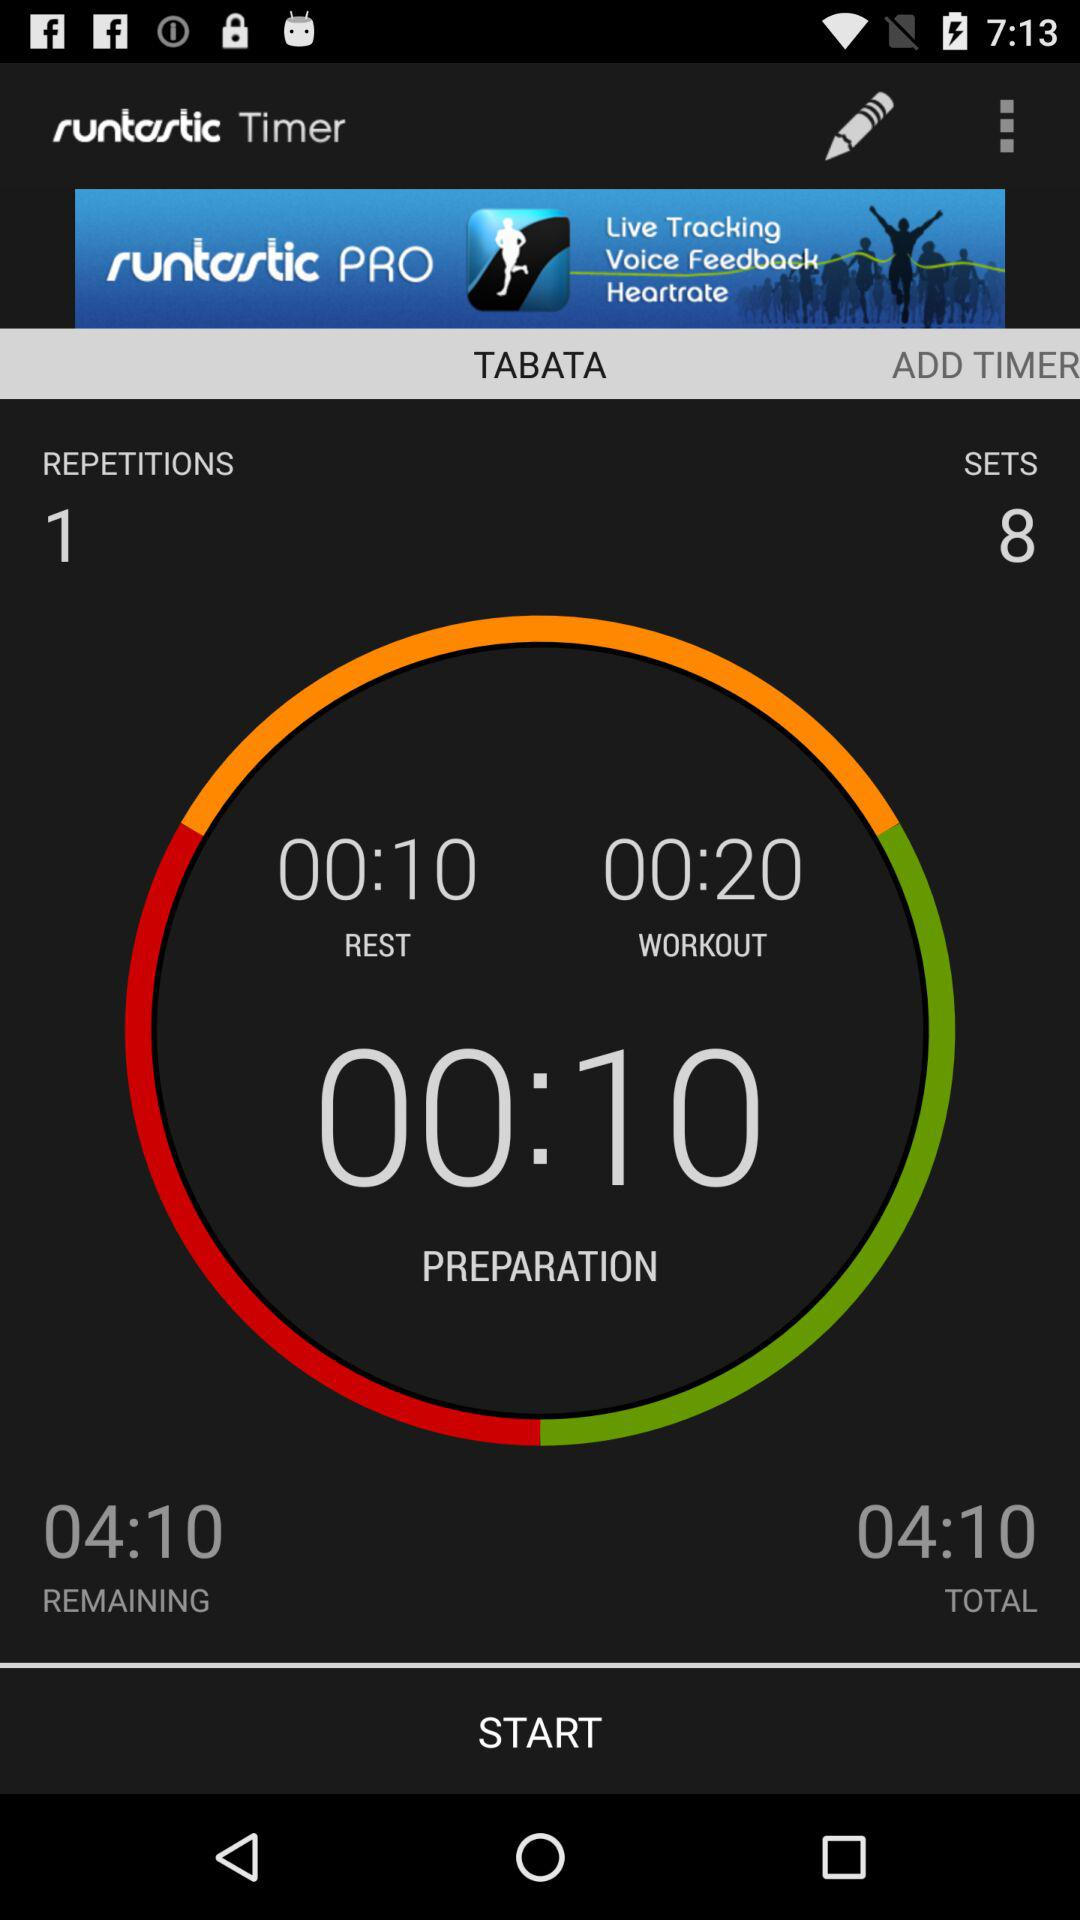How many sets are there?
Answer the question using a single word or phrase. 8 